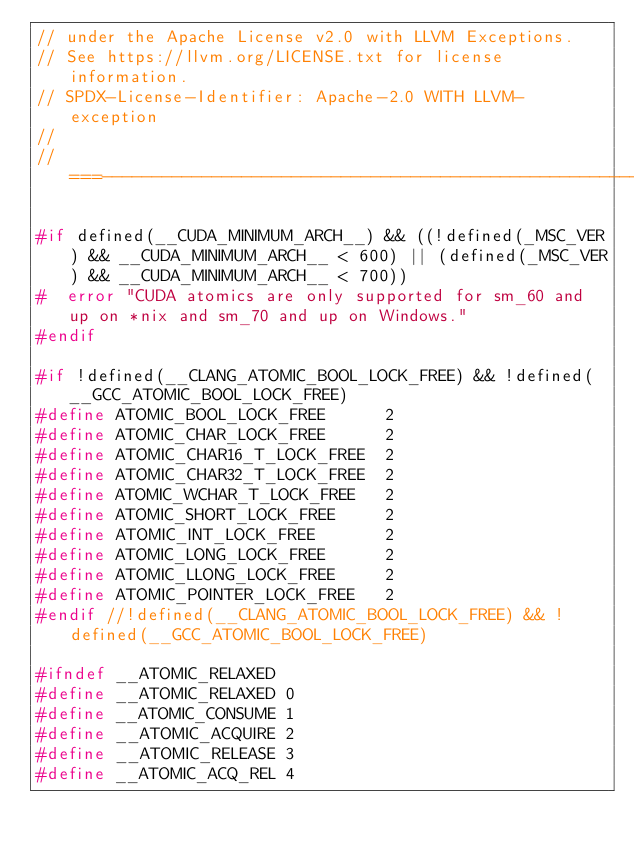Convert code to text. <code><loc_0><loc_0><loc_500><loc_500><_C_>// under the Apache License v2.0 with LLVM Exceptions.
// See https://llvm.org/LICENSE.txt for license information.
// SPDX-License-Identifier: Apache-2.0 WITH LLVM-exception
//
//===----------------------------------------------------------------------===//

#if defined(__CUDA_MINIMUM_ARCH__) && ((!defined(_MSC_VER) && __CUDA_MINIMUM_ARCH__ < 600) || (defined(_MSC_VER) && __CUDA_MINIMUM_ARCH__ < 700))
#  error "CUDA atomics are only supported for sm_60 and up on *nix and sm_70 and up on Windows."
#endif

#if !defined(__CLANG_ATOMIC_BOOL_LOCK_FREE) && !defined(__GCC_ATOMIC_BOOL_LOCK_FREE)
#define ATOMIC_BOOL_LOCK_FREE      2
#define ATOMIC_CHAR_LOCK_FREE      2
#define ATOMIC_CHAR16_T_LOCK_FREE  2
#define ATOMIC_CHAR32_T_LOCK_FREE  2
#define ATOMIC_WCHAR_T_LOCK_FREE   2
#define ATOMIC_SHORT_LOCK_FREE     2
#define ATOMIC_INT_LOCK_FREE       2
#define ATOMIC_LONG_LOCK_FREE      2
#define ATOMIC_LLONG_LOCK_FREE     2
#define ATOMIC_POINTER_LOCK_FREE   2
#endif //!defined(__CLANG_ATOMIC_BOOL_LOCK_FREE) && !defined(__GCC_ATOMIC_BOOL_LOCK_FREE)

#ifndef __ATOMIC_RELAXED
#define __ATOMIC_RELAXED 0
#define __ATOMIC_CONSUME 1
#define __ATOMIC_ACQUIRE 2
#define __ATOMIC_RELEASE 3
#define __ATOMIC_ACQ_REL 4</code> 